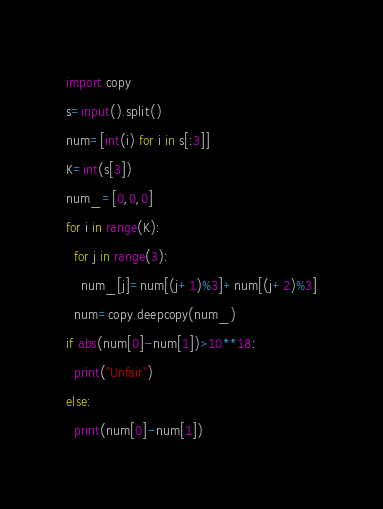<code> <loc_0><loc_0><loc_500><loc_500><_Python_>import copy
s=input().split()
num=[int(i) for i in s[:3]]
K=int(s[3])
num_=[0,0,0]
for i in range(K):
  for j in range(3):
    num_[j]=num[(j+1)%3]+num[(j+2)%3]
  num=copy.deepcopy(num_)
if abs(num[0]-num[1])>10**18:
  print("Unfair")
else:
  print(num[0]-num[1])</code> 